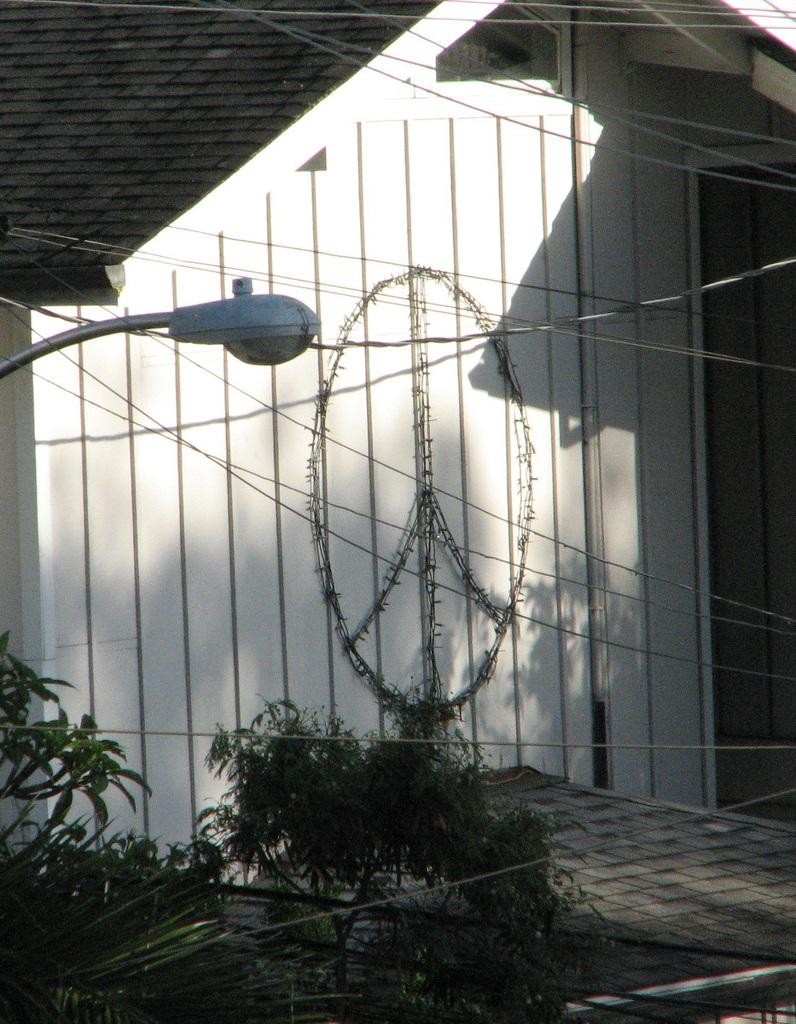What type of living organisms can be seen in the image? Plants can be seen in the image. What type of structure is present in the image? There is a building in the image. Can you describe any specific features of the building? There is a logo on the wall of the building. What else can be seen in the image besides the plants and building? Wires and a light pole are visible in the image. How many wheels are visible on the plants in the image? There are no wheels present on the plants in the image, as plants do not have wheels. 